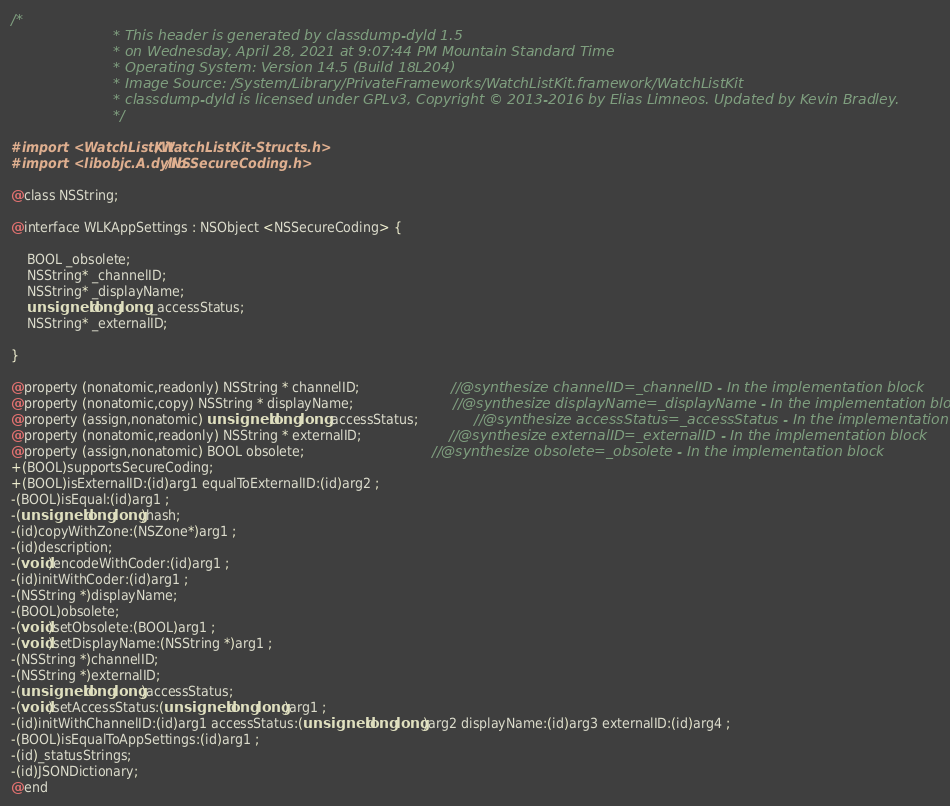Convert code to text. <code><loc_0><loc_0><loc_500><loc_500><_C_>/*
                       * This header is generated by classdump-dyld 1.5
                       * on Wednesday, April 28, 2021 at 9:07:44 PM Mountain Standard Time
                       * Operating System: Version 14.5 (Build 18L204)
                       * Image Source: /System/Library/PrivateFrameworks/WatchListKit.framework/WatchListKit
                       * classdump-dyld is licensed under GPLv3, Copyright © 2013-2016 by Elias Limneos. Updated by Kevin Bradley.
                       */

#import <WatchListKit/WatchListKit-Structs.h>
#import <libobjc.A.dylib/NSSecureCoding.h>

@class NSString;

@interface WLKAppSettings : NSObject <NSSecureCoding> {

	BOOL _obsolete;
	NSString* _channelID;
	NSString* _displayName;
	unsigned long long _accessStatus;
	NSString* _externalID;

}

@property (nonatomic,readonly) NSString * channelID;                       //@synthesize channelID=_channelID - In the implementation block
@property (nonatomic,copy) NSString * displayName;                         //@synthesize displayName=_displayName - In the implementation block
@property (assign,nonatomic) unsigned long long accessStatus;              //@synthesize accessStatus=_accessStatus - In the implementation block
@property (nonatomic,readonly) NSString * externalID;                      //@synthesize externalID=_externalID - In the implementation block
@property (assign,nonatomic) BOOL obsolete;                                //@synthesize obsolete=_obsolete - In the implementation block
+(BOOL)supportsSecureCoding;
+(BOOL)isExternalID:(id)arg1 equalToExternalID:(id)arg2 ;
-(BOOL)isEqual:(id)arg1 ;
-(unsigned long long)hash;
-(id)copyWithZone:(NSZone*)arg1 ;
-(id)description;
-(void)encodeWithCoder:(id)arg1 ;
-(id)initWithCoder:(id)arg1 ;
-(NSString *)displayName;
-(BOOL)obsolete;
-(void)setObsolete:(BOOL)arg1 ;
-(void)setDisplayName:(NSString *)arg1 ;
-(NSString *)channelID;
-(NSString *)externalID;
-(unsigned long long)accessStatus;
-(void)setAccessStatus:(unsigned long long)arg1 ;
-(id)initWithChannelID:(id)arg1 accessStatus:(unsigned long long)arg2 displayName:(id)arg3 externalID:(id)arg4 ;
-(BOOL)isEqualToAppSettings:(id)arg1 ;
-(id)_statusStrings;
-(id)JSONDictionary;
@end

</code> 